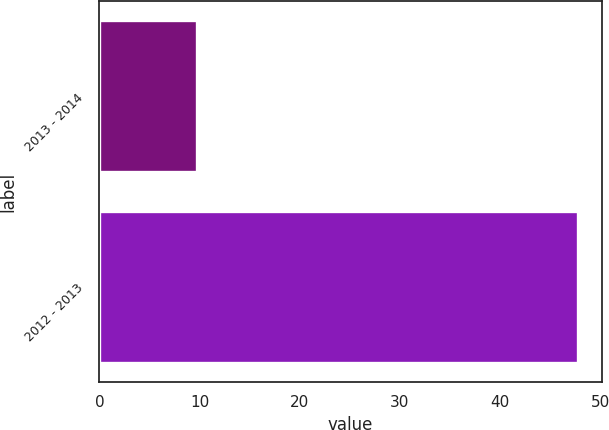<chart> <loc_0><loc_0><loc_500><loc_500><bar_chart><fcel>2013 - 2014<fcel>2012 - 2013<nl><fcel>9.8<fcel>47.8<nl></chart> 